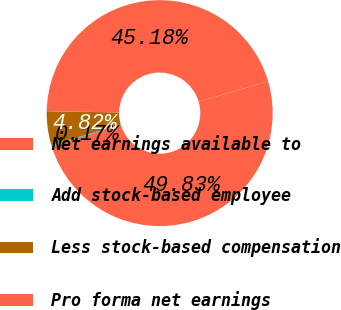Convert chart to OTSL. <chart><loc_0><loc_0><loc_500><loc_500><pie_chart><fcel>Net earnings available to<fcel>Add stock-based employee<fcel>Less stock-based compensation<fcel>Pro forma net earnings<nl><fcel>49.83%<fcel>0.17%<fcel>4.82%<fcel>45.18%<nl></chart> 